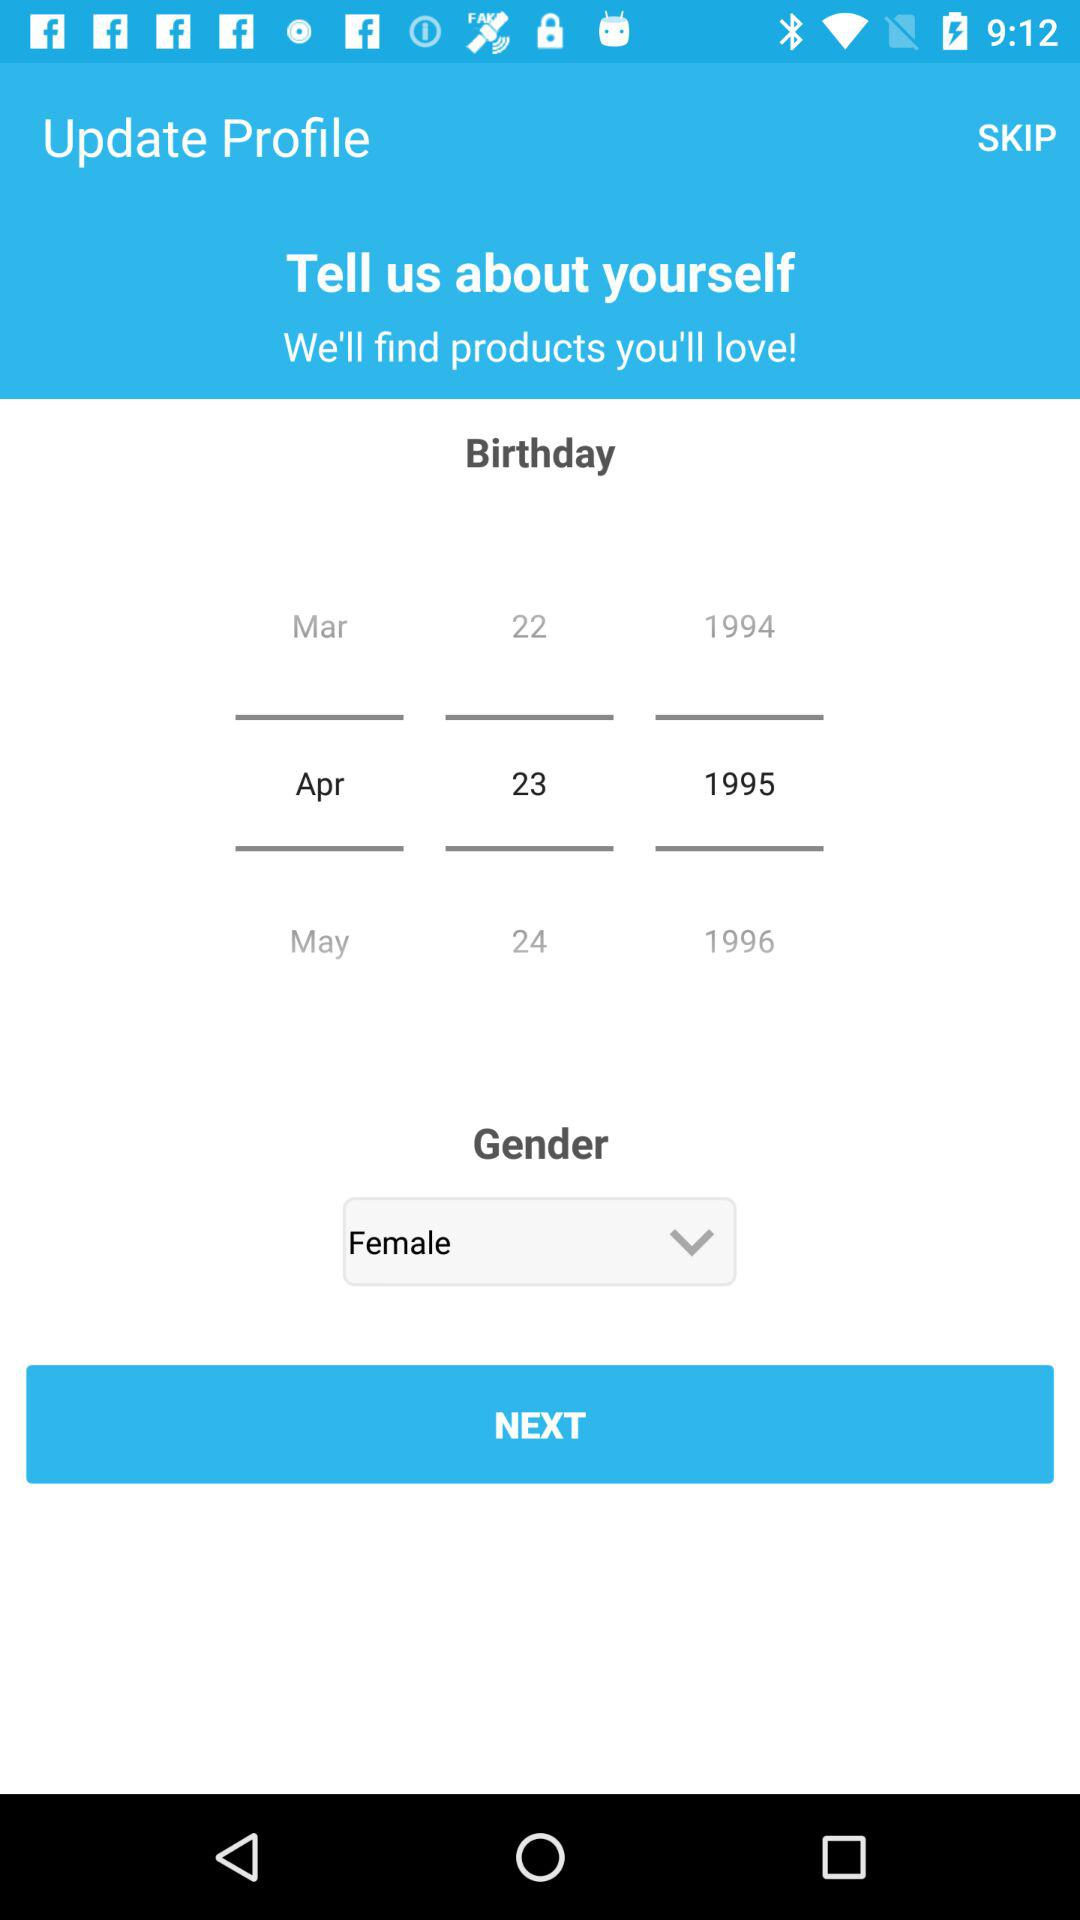What is the gender? The gender is female. 